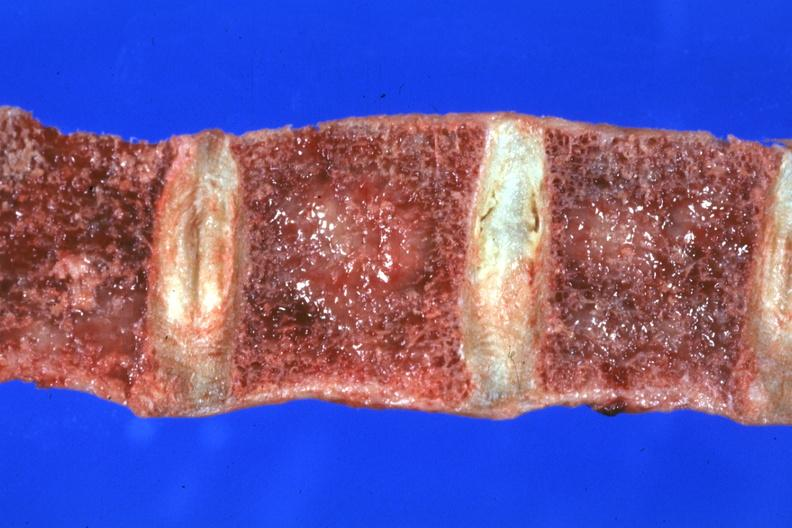what does this image show?
Answer the question using a single word or phrase. Close-up view of frontal section vertebral bodies excellent 